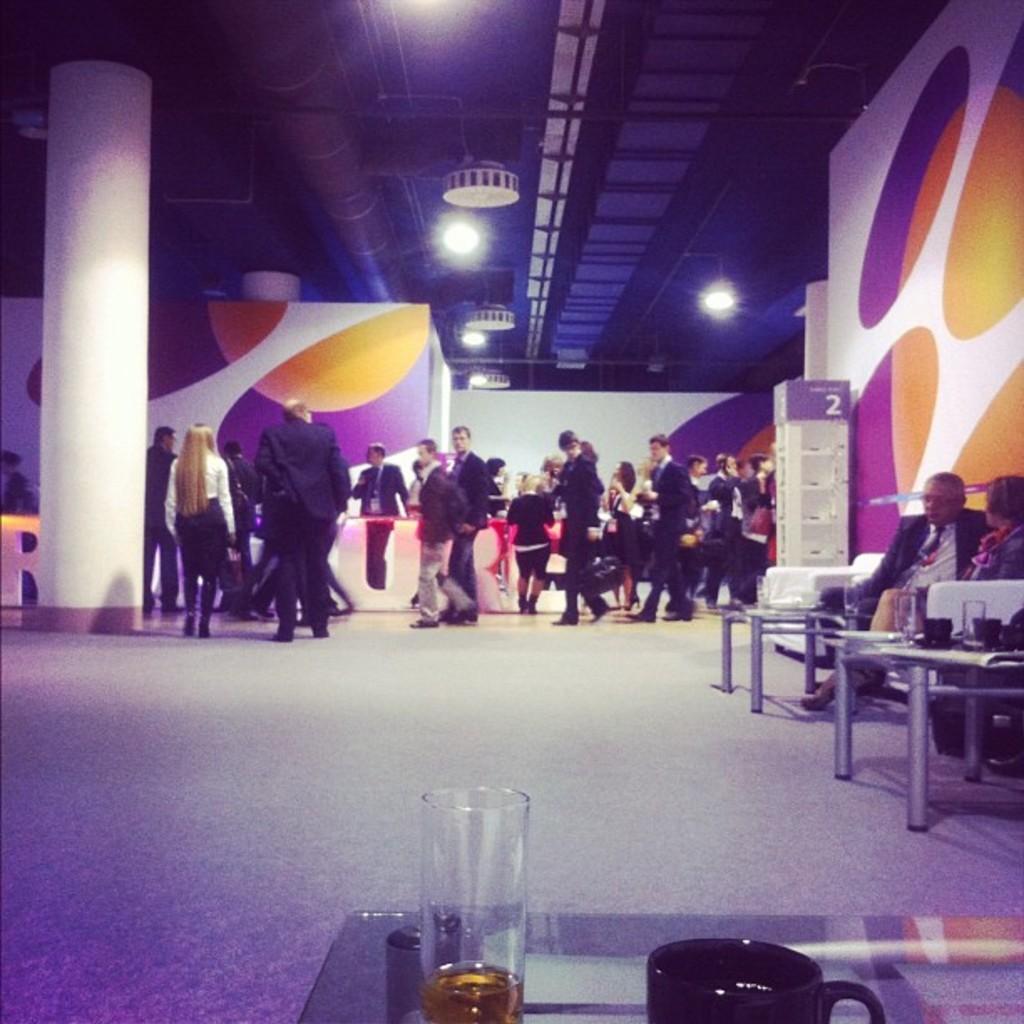Describe this image in one or two sentences. This image is taken indoors. At the bottom of the image there is a floor and a table with a glass of wine and a cup on it. At the top of the image there is a ceiling with lights. In the background there is a wall, a pillar and many people are standing on the floor and a few are walking on the floor. On the right side of the image there is a wall and there are two tables with a few things on them. A man and a woman are sitting on the sofa. 